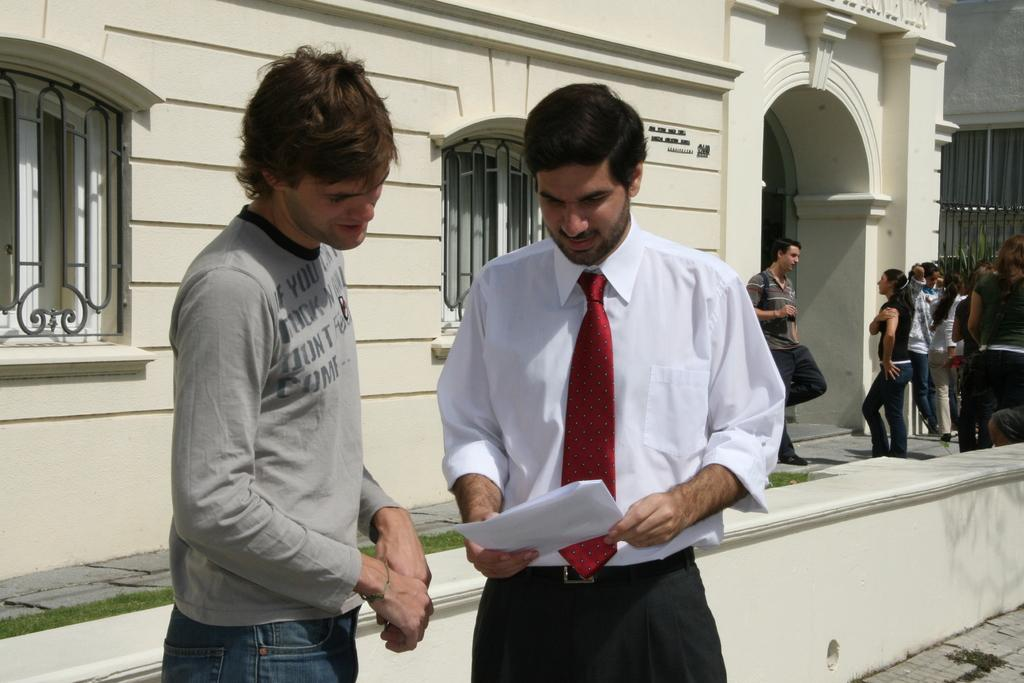How many people are present in the image? There are two men standing in the image. What are the men doing in the image? The men are engaging with each other with each other. What can be seen in the background of the image? There is a building, windows, a grill, grass, and a crowd visible in the background. What type of dinner is being prepared on the volcano in the image? There is no volcano or dinner preparation present in the image. Who is the friend that the men are talking to in the image? The provided facts do not mention a third person or friend in the image. 